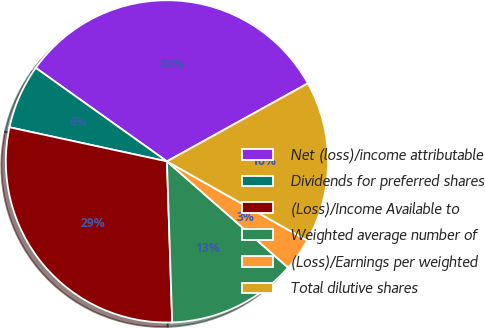Convert chart to OTSL. <chart><loc_0><loc_0><loc_500><loc_500><pie_chart><fcel>Net (loss)/income attributable<fcel>Dividends for preferred shares<fcel>(Loss)/Income Available to<fcel>Weighted average number of<fcel>(Loss)/Earnings per weighted<fcel>Total dilutive shares<nl><fcel>32.1%<fcel>6.46%<fcel>28.92%<fcel>13.03%<fcel>3.28%<fcel>16.22%<nl></chart> 